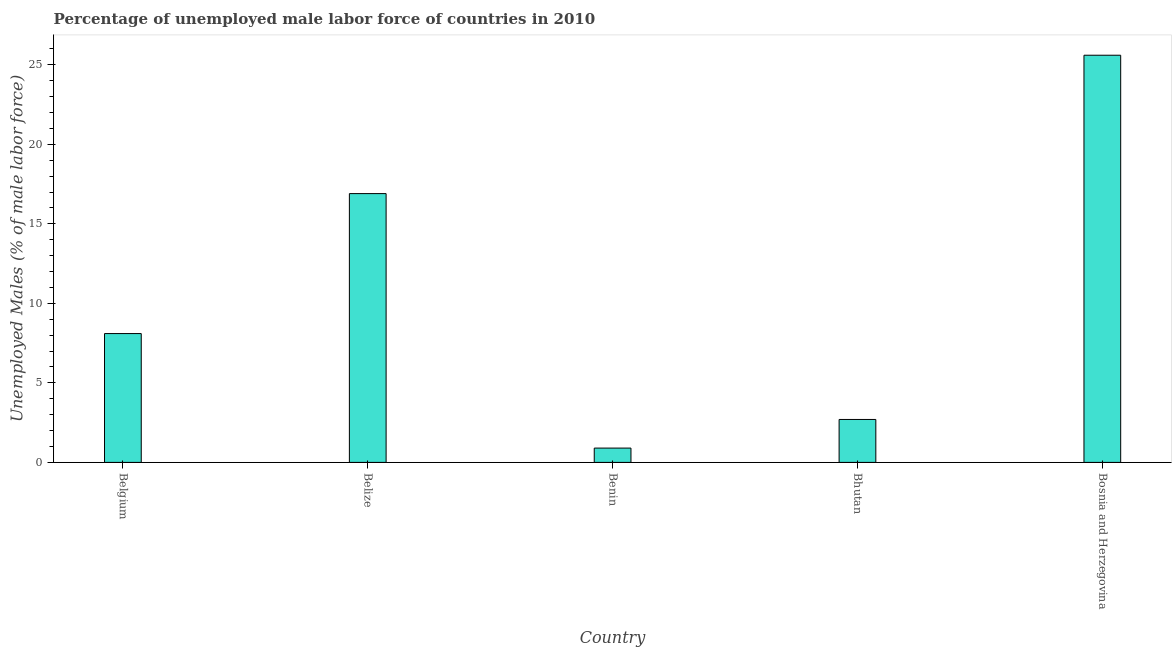Does the graph contain any zero values?
Provide a succinct answer. No. Does the graph contain grids?
Ensure brevity in your answer.  No. What is the title of the graph?
Keep it short and to the point. Percentage of unemployed male labor force of countries in 2010. What is the label or title of the Y-axis?
Keep it short and to the point. Unemployed Males (% of male labor force). What is the total unemployed male labour force in Bosnia and Herzegovina?
Provide a short and direct response. 25.6. Across all countries, what is the maximum total unemployed male labour force?
Give a very brief answer. 25.6. Across all countries, what is the minimum total unemployed male labour force?
Your response must be concise. 0.9. In which country was the total unemployed male labour force maximum?
Make the answer very short. Bosnia and Herzegovina. In which country was the total unemployed male labour force minimum?
Offer a very short reply. Benin. What is the sum of the total unemployed male labour force?
Your response must be concise. 54.2. What is the difference between the total unemployed male labour force in Belgium and Belize?
Give a very brief answer. -8.8. What is the average total unemployed male labour force per country?
Make the answer very short. 10.84. What is the median total unemployed male labour force?
Ensure brevity in your answer.  8.1. What is the ratio of the total unemployed male labour force in Belize to that in Benin?
Your answer should be compact. 18.78. What is the difference between the highest and the second highest total unemployed male labour force?
Make the answer very short. 8.7. What is the difference between the highest and the lowest total unemployed male labour force?
Your answer should be very brief. 24.7. In how many countries, is the total unemployed male labour force greater than the average total unemployed male labour force taken over all countries?
Your answer should be compact. 2. How many countries are there in the graph?
Your response must be concise. 5. Are the values on the major ticks of Y-axis written in scientific E-notation?
Offer a terse response. No. What is the Unemployed Males (% of male labor force) in Belgium?
Provide a short and direct response. 8.1. What is the Unemployed Males (% of male labor force) in Belize?
Give a very brief answer. 16.9. What is the Unemployed Males (% of male labor force) in Benin?
Your response must be concise. 0.9. What is the Unemployed Males (% of male labor force) of Bhutan?
Keep it short and to the point. 2.7. What is the Unemployed Males (% of male labor force) of Bosnia and Herzegovina?
Offer a very short reply. 25.6. What is the difference between the Unemployed Males (% of male labor force) in Belgium and Belize?
Your answer should be compact. -8.8. What is the difference between the Unemployed Males (% of male labor force) in Belgium and Bhutan?
Make the answer very short. 5.4. What is the difference between the Unemployed Males (% of male labor force) in Belgium and Bosnia and Herzegovina?
Make the answer very short. -17.5. What is the difference between the Unemployed Males (% of male labor force) in Belize and Bhutan?
Provide a succinct answer. 14.2. What is the difference between the Unemployed Males (% of male labor force) in Belize and Bosnia and Herzegovina?
Give a very brief answer. -8.7. What is the difference between the Unemployed Males (% of male labor force) in Benin and Bhutan?
Give a very brief answer. -1.8. What is the difference between the Unemployed Males (% of male labor force) in Benin and Bosnia and Herzegovina?
Your answer should be very brief. -24.7. What is the difference between the Unemployed Males (% of male labor force) in Bhutan and Bosnia and Herzegovina?
Provide a succinct answer. -22.9. What is the ratio of the Unemployed Males (% of male labor force) in Belgium to that in Belize?
Keep it short and to the point. 0.48. What is the ratio of the Unemployed Males (% of male labor force) in Belgium to that in Benin?
Keep it short and to the point. 9. What is the ratio of the Unemployed Males (% of male labor force) in Belgium to that in Bosnia and Herzegovina?
Your response must be concise. 0.32. What is the ratio of the Unemployed Males (% of male labor force) in Belize to that in Benin?
Provide a succinct answer. 18.78. What is the ratio of the Unemployed Males (% of male labor force) in Belize to that in Bhutan?
Provide a short and direct response. 6.26. What is the ratio of the Unemployed Males (% of male labor force) in Belize to that in Bosnia and Herzegovina?
Provide a succinct answer. 0.66. What is the ratio of the Unemployed Males (% of male labor force) in Benin to that in Bhutan?
Your response must be concise. 0.33. What is the ratio of the Unemployed Males (% of male labor force) in Benin to that in Bosnia and Herzegovina?
Provide a short and direct response. 0.04. What is the ratio of the Unemployed Males (% of male labor force) in Bhutan to that in Bosnia and Herzegovina?
Your response must be concise. 0.1. 